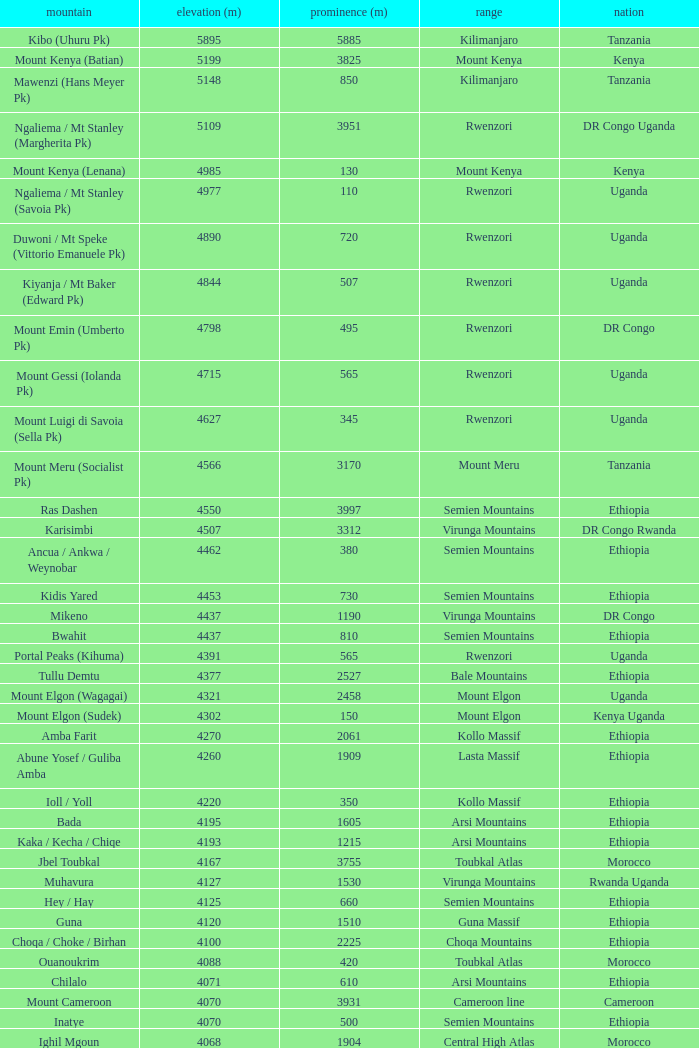How tall is the Mountain of jbel ghat? 1.0. 